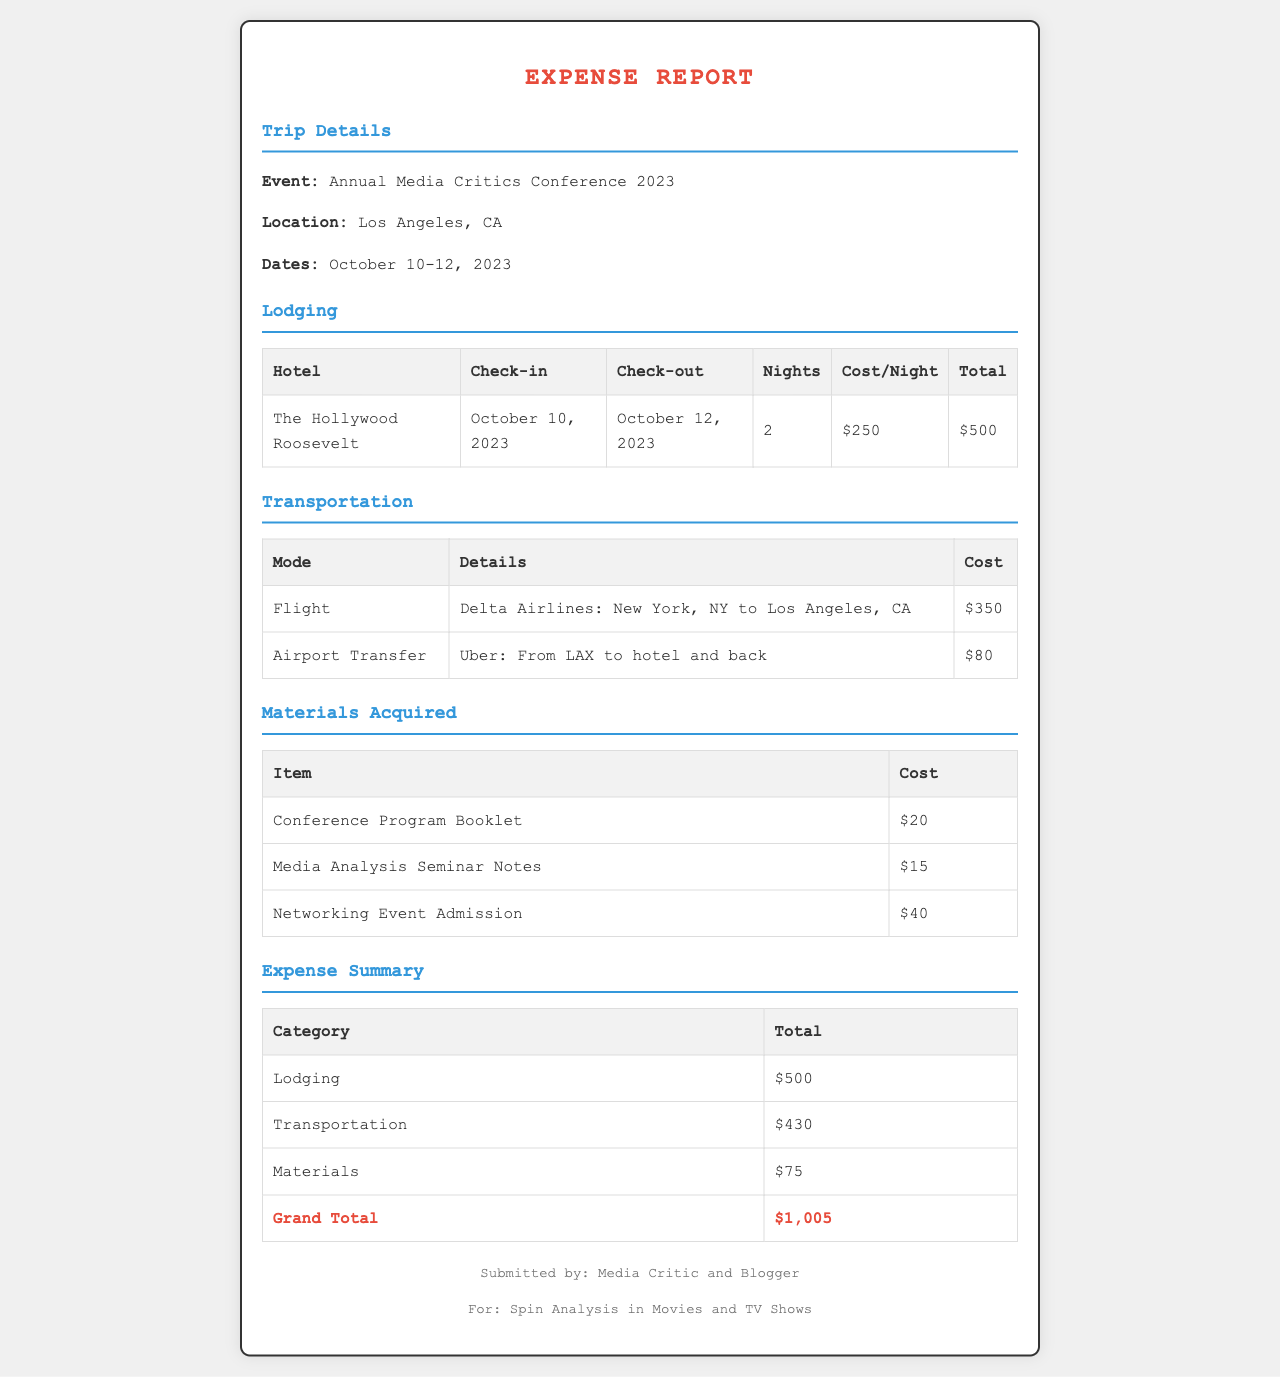What is the location of the conference? The document states that the event is located in Los Angeles, CA.
Answer: Los Angeles, CA How many nights did the lodging last? The lodging section indicates that the stay was for 2 nights.
Answer: 2 What was the total cost of transportation? The transportation section shows the flight and airport transfer costs, which total $430.
Answer: $430 What is the cost of the Conference Program Booklet? The materials acquired section lists the cost of the Conference Program Booklet as $20.
Answer: $20 What is the Grand Total of the expense report? The expense summary section provides the Grand Total as $1,005.
Answer: $1,005 